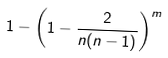Convert formula to latex. <formula><loc_0><loc_0><loc_500><loc_500>1 - \left ( 1 - { \frac { 2 } { n ( n - 1 ) } } \right ) ^ { m }</formula> 